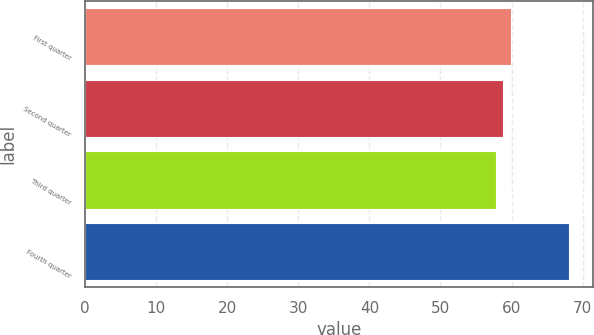Convert chart. <chart><loc_0><loc_0><loc_500><loc_500><bar_chart><fcel>First quarter<fcel>Second quarter<fcel>Third quarter<fcel>Fourth quarter<nl><fcel>59.86<fcel>58.83<fcel>57.8<fcel>68.1<nl></chart> 